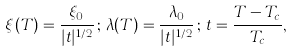<formula> <loc_0><loc_0><loc_500><loc_500>\xi ( T ) = \frac { \xi _ { 0 } } { | t | ^ { 1 / 2 } } \, ; \, \lambda ( T ) = \frac { \lambda _ { 0 } } { | t | ^ { 1 / 2 } } \, ; \, t = \frac { T - T _ { c } } { T _ { c } } ,</formula> 